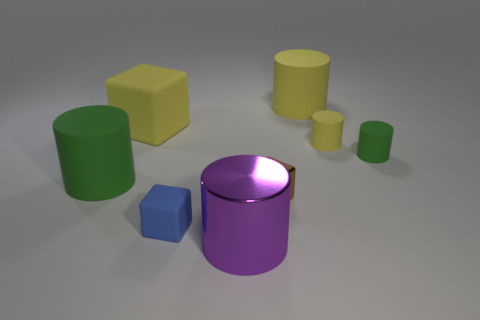What number of objects are objects in front of the yellow rubber cube or big gray matte cubes?
Offer a very short reply. 6. Is there another large shiny object that has the same shape as the brown object?
Offer a terse response. No. Are there the same number of small blue things behind the small blue rubber cube and big gray rubber things?
Your answer should be compact. Yes. How many yellow rubber blocks have the same size as the purple thing?
Your answer should be very brief. 1. What number of big cylinders are left of the tiny green cylinder?
Make the answer very short. 3. What is the material of the big thing that is in front of the green object that is left of the yellow block?
Offer a very short reply. Metal. Is there a cylinder that has the same color as the big rubber cube?
Provide a succinct answer. Yes. There is a yellow cube that is made of the same material as the big green cylinder; what size is it?
Your response must be concise. Large. Are there any other things of the same color as the large rubber block?
Your response must be concise. Yes. The tiny rubber thing to the left of the large purple cylinder is what color?
Your response must be concise. Blue. 